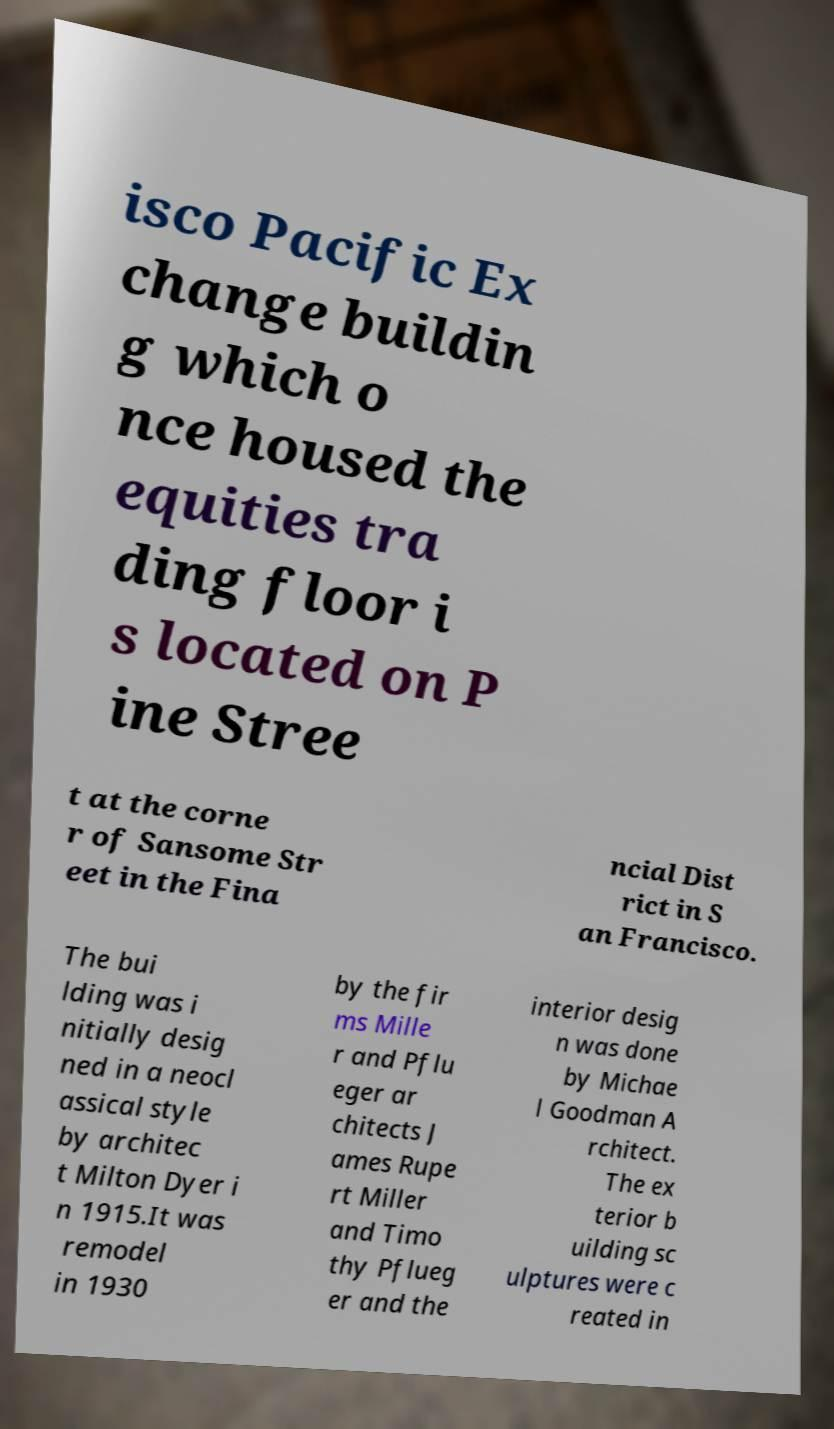For documentation purposes, I need the text within this image transcribed. Could you provide that? isco Pacific Ex change buildin g which o nce housed the equities tra ding floor i s located on P ine Stree t at the corne r of Sansome Str eet in the Fina ncial Dist rict in S an Francisco. The bui lding was i nitially desig ned in a neocl assical style by architec t Milton Dyer i n 1915.It was remodel in 1930 by the fir ms Mille r and Pflu eger ar chitects J ames Rupe rt Miller and Timo thy Pflueg er and the interior desig n was done by Michae l Goodman A rchitect. The ex terior b uilding sc ulptures were c reated in 